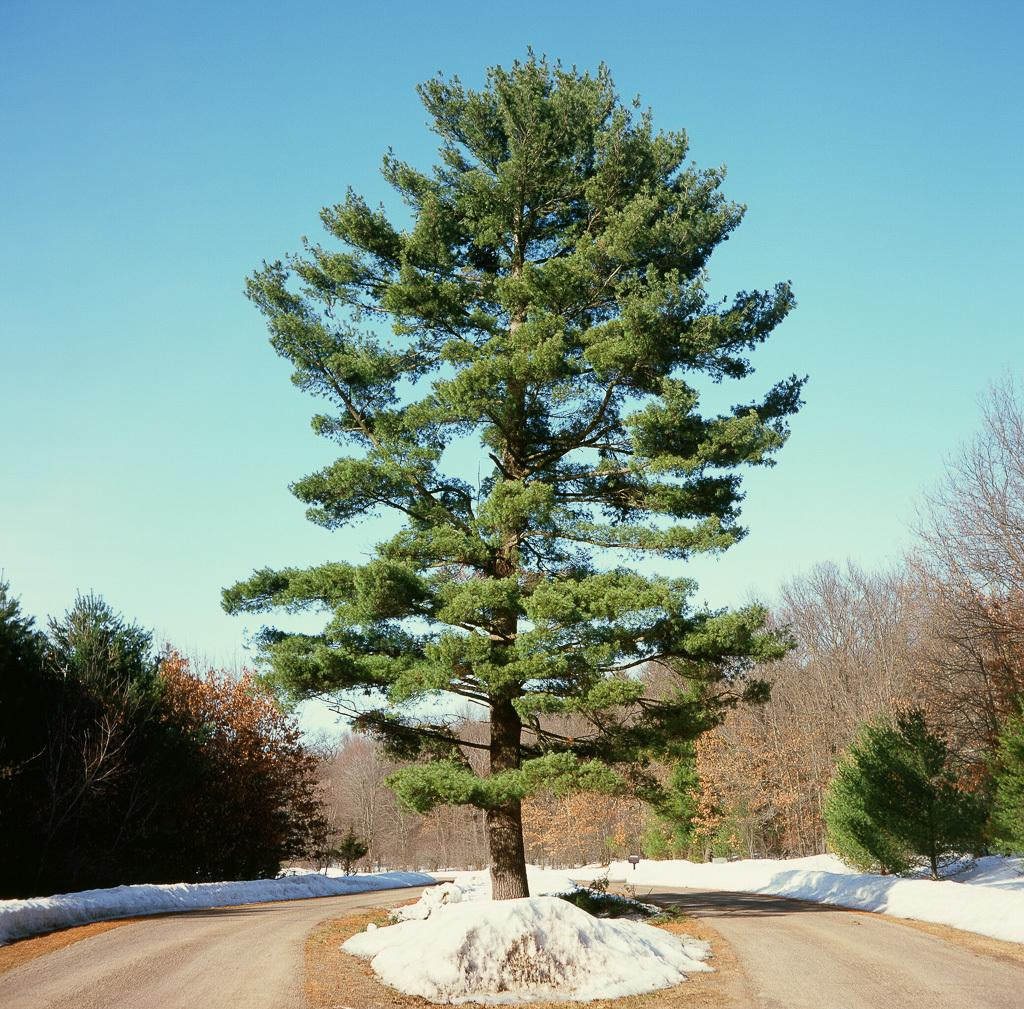What type of vegetation can be seen in the image? There are trees in the image. What type of pathway is present in the image? There is a road in the image. What part of the natural environment is visible in the image? The sky is visible in the image. What color crayon is being used to draw on the road in the image? There is no crayon or drawing present on the road in the image. 